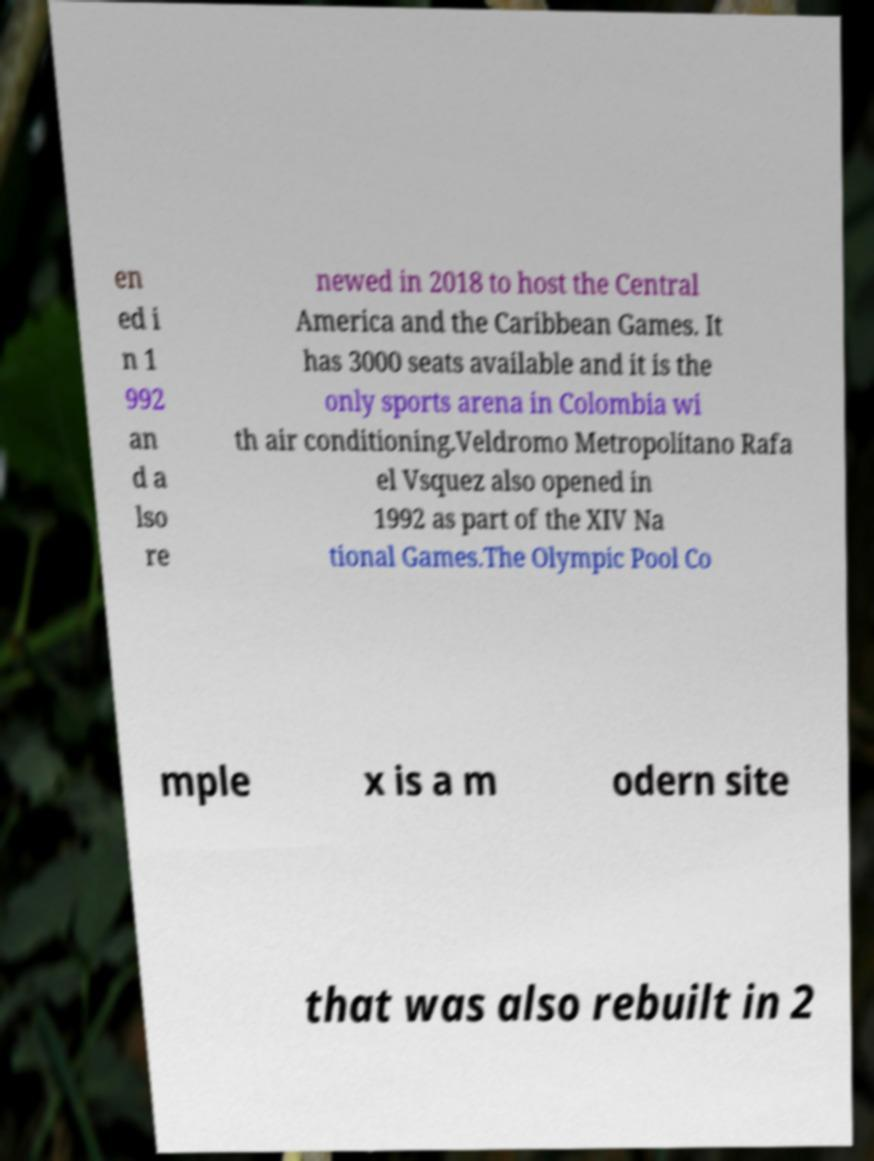Can you accurately transcribe the text from the provided image for me? en ed i n 1 992 an d a lso re newed in 2018 to host the Central America and the Caribbean Games. It has 3000 seats available and it is the only sports arena in Colombia wi th air conditioning.Veldromo Metropolitano Rafa el Vsquez also opened in 1992 as part of the XIV Na tional Games.The Olympic Pool Co mple x is a m odern site that was also rebuilt in 2 